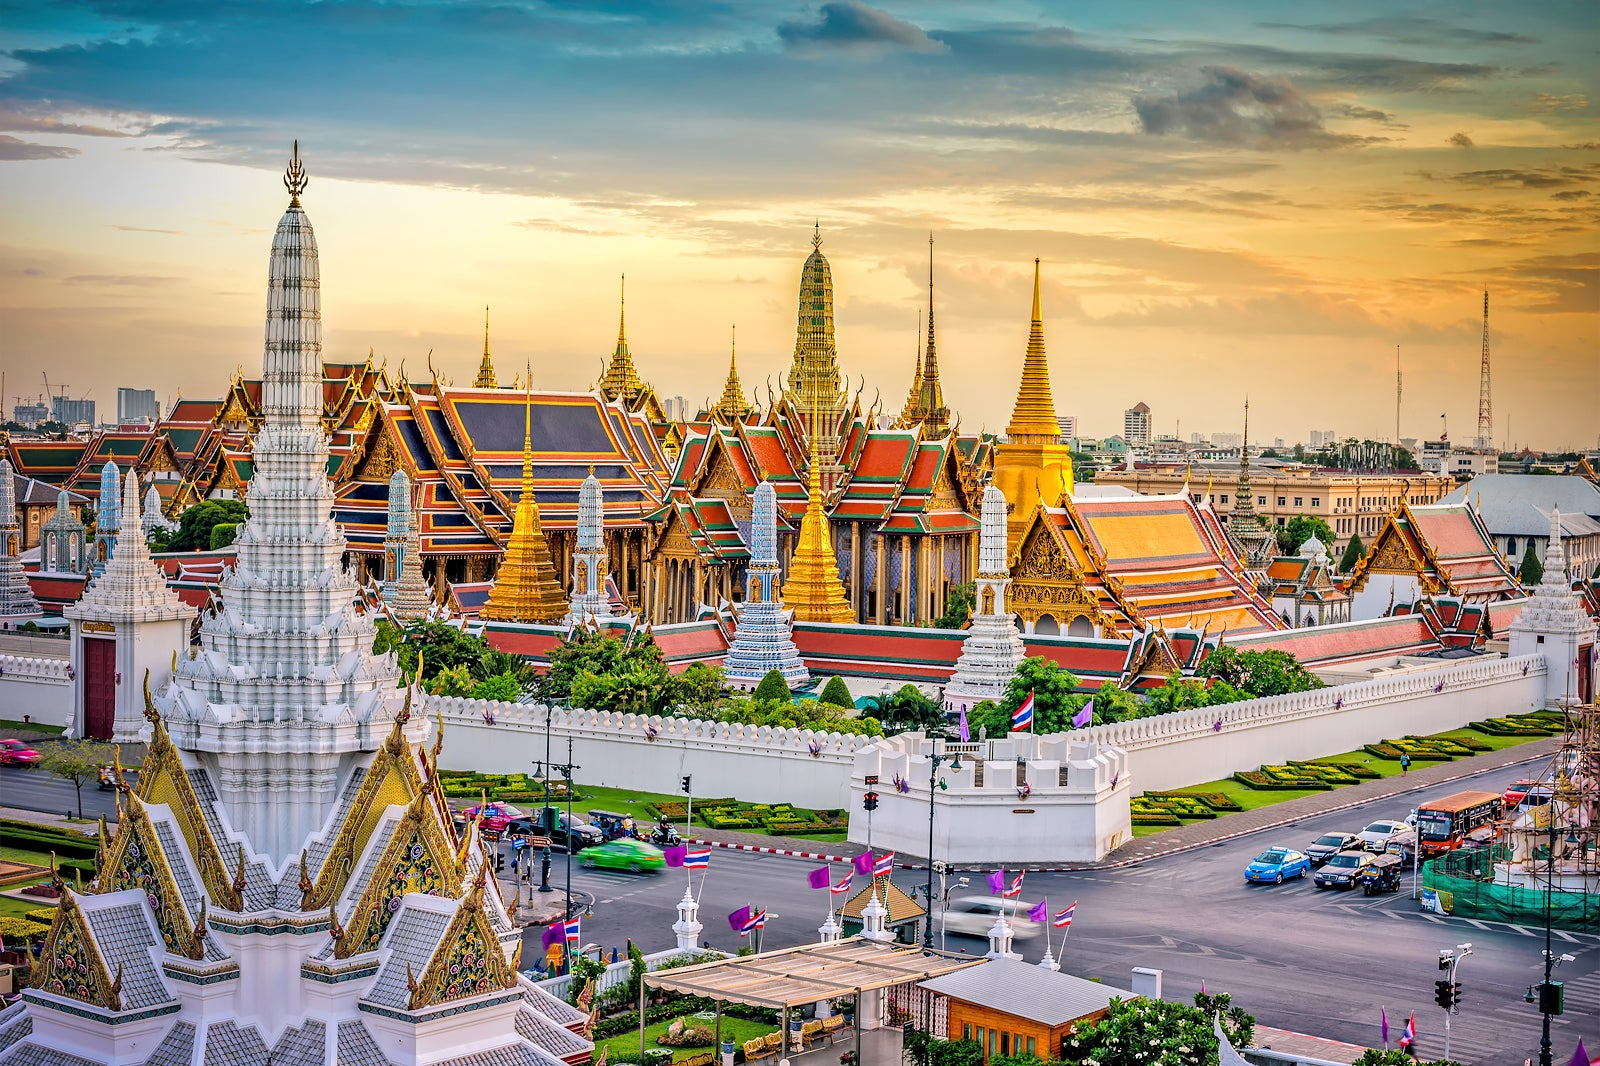Describe the following image. The image beautifully captures the Grand Palace in Bangkok, Thailand, a symbol of majesty and splendor. The palace complex showcases traditional Thai architecture with multicolored roofs in vibrant shades of red and gold, adorned with intricate designs. Numerous ornate spires and pagodas rise from the structures, highlighting the elaborate craftsmanship. Encased within pristine, white walls with a prominent gate, the palace exudes grandeur. The elevated perspective provides a panoramic view, not only of the palace but of Bangkok's city skyline under an expansive, cloud-filled sky. The scene encapsulates the architectural magnificence of the Grand Palace and its prominence in the urban tapestry of Bangkok. 